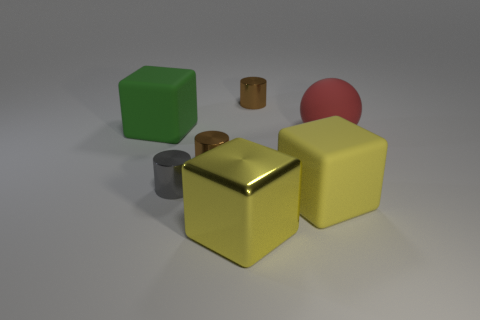What is the color of the metal block?
Your response must be concise. Yellow. Is there any other thing that is the same shape as the big red rubber thing?
Ensure brevity in your answer.  No. The other large matte thing that is the same shape as the green rubber object is what color?
Ensure brevity in your answer.  Yellow. Is the shape of the gray metallic object the same as the yellow matte thing?
Provide a short and direct response. No. How many blocks are yellow matte objects or large green rubber things?
Your answer should be very brief. 2. What is the color of the large block that is the same material as the small gray cylinder?
Ensure brevity in your answer.  Yellow. There is a matte thing to the left of the yellow metallic thing; does it have the same size as the small gray metallic cylinder?
Offer a terse response. No. Is the big green block made of the same material as the block to the right of the metal cube?
Offer a very short reply. Yes. There is a small object on the right side of the metallic cube; what color is it?
Provide a short and direct response. Brown. Is there a tiny metallic thing behind the metallic block that is to the right of the green matte block?
Ensure brevity in your answer.  Yes. 